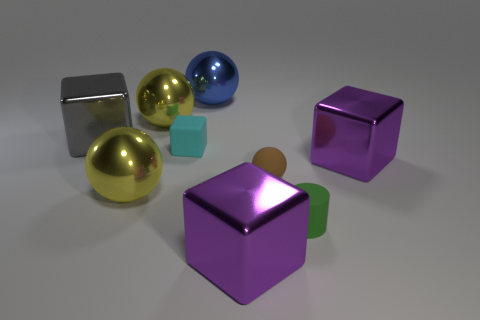Subtract all shiny cubes. How many cubes are left? 1 Add 1 small green things. How many objects exist? 10 Subtract 2 spheres. How many spheres are left? 2 Subtract all yellow balls. How many balls are left? 2 Subtract all blocks. How many objects are left? 5 Subtract 0 green spheres. How many objects are left? 9 Subtract all green blocks. Subtract all gray cylinders. How many blocks are left? 4 Subtract all cyan blocks. How many blue cylinders are left? 0 Subtract all metallic spheres. Subtract all tiny brown matte balls. How many objects are left? 5 Add 6 yellow things. How many yellow things are left? 8 